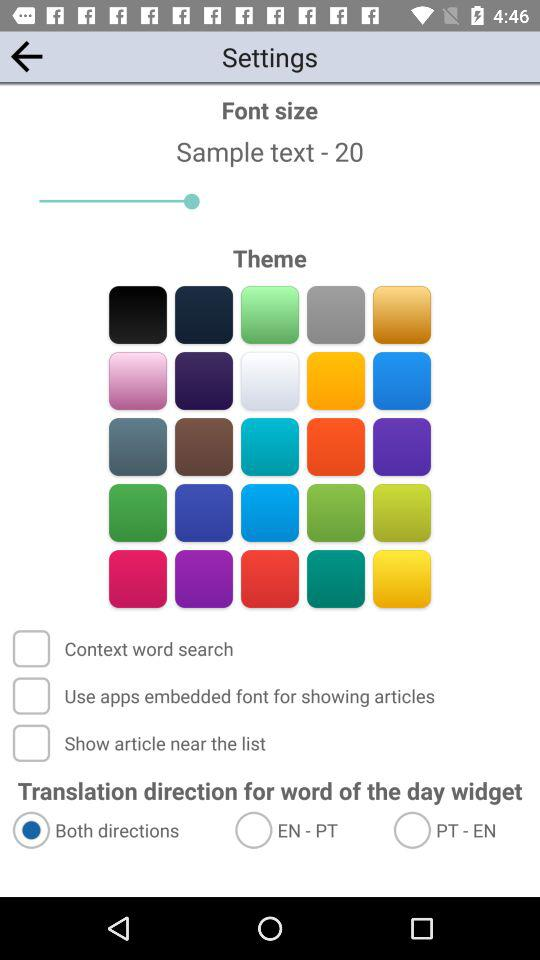What option has been selected? The selected option is "Both directions". 